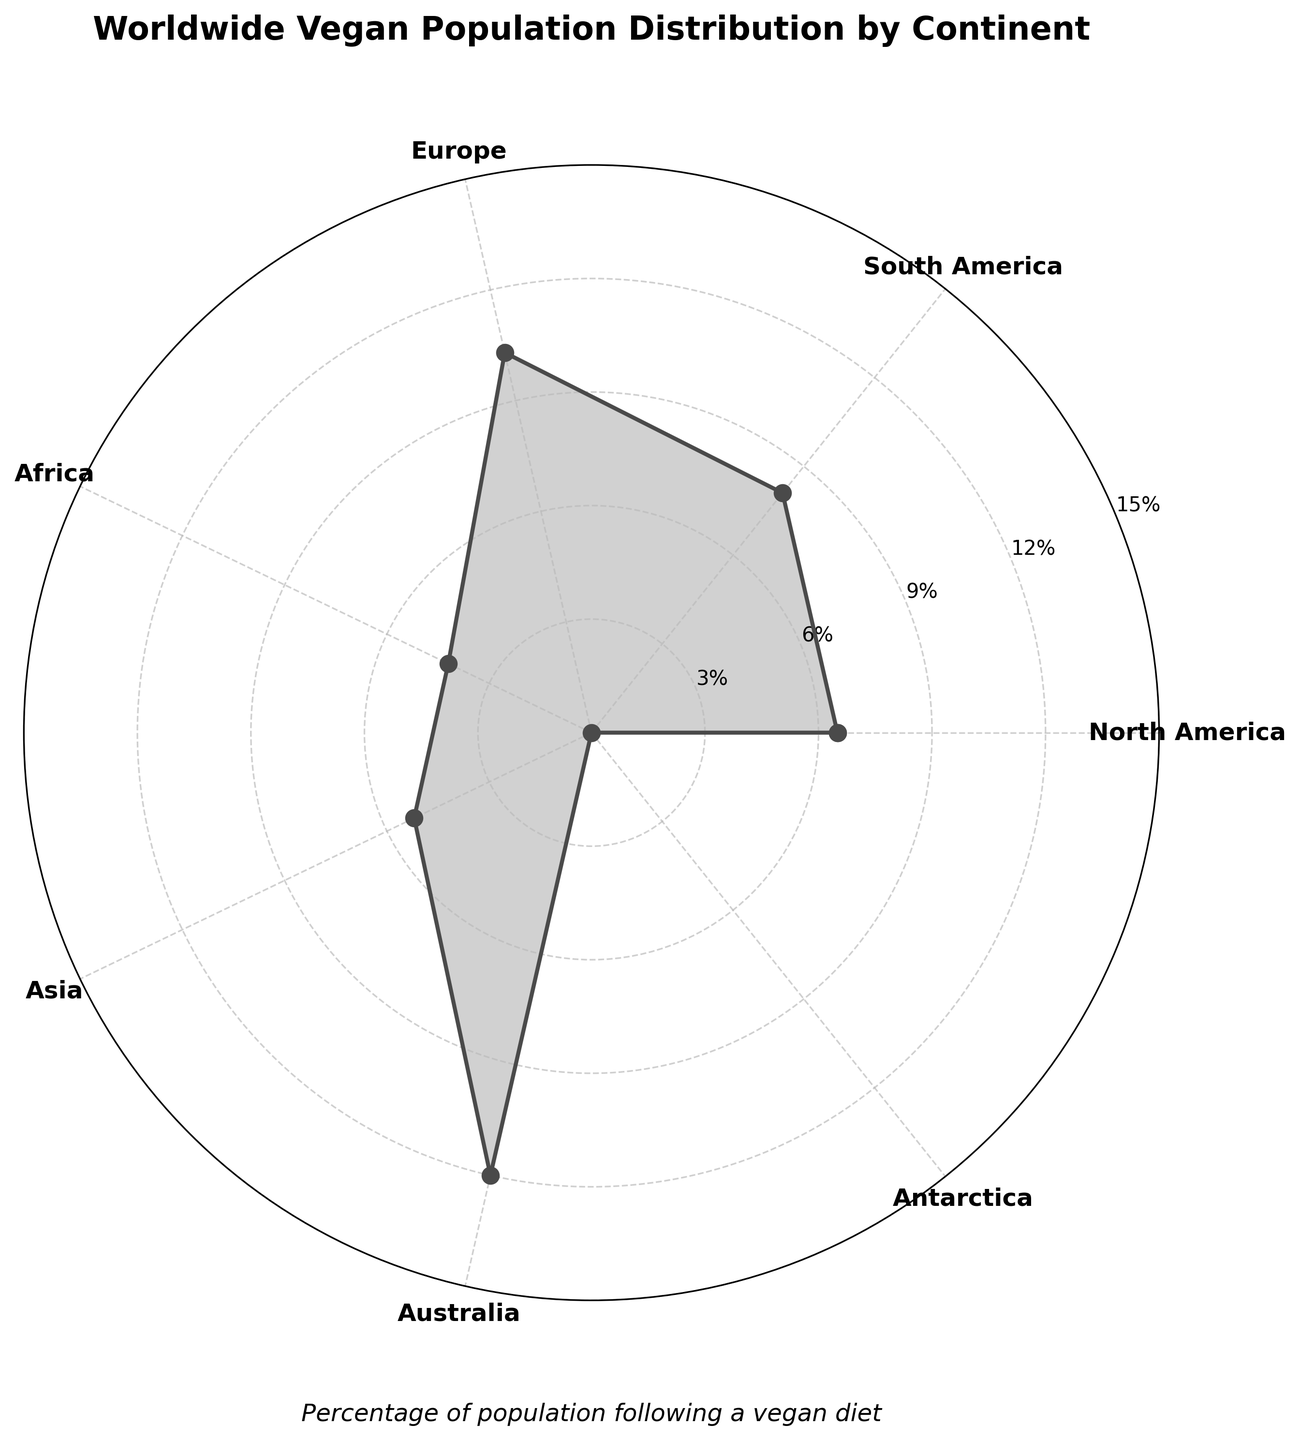How many continents are represented in the plot? There are data points for North America, South America, Europe, Africa, Asia, Australia, and Antarctica. By counting them, we get 7 continents.
Answer: 7 Which continent has the highest percentage of vegan population? By examining the plot, Australia has the highest percentage with 12.0%.
Answer: Australia Which continent has the lowest percentage of vegan population? According to the plot, Antarctica has the lowest percentage of vegan population, which is 0.0%.
Answer: Antarctica What is the difference in the percentage of vegan population between Europe and Africa? The vegan population percentage in Europe is 10.3% and in Africa is 4.2%. Subtracting these values (10.3% - 4.2%) gives us 6.1%.
Answer: 6.1% What is the average vegan population percentage across all continents? The percentages are 6.5% for North America, 8.1% for South America, 10.3% for Europe, 4.2% for Africa, 5.2% for Asia, 12.0% for Australia, and 0.0% for Antarctica. Summing these percentages (6.5 + 8.1 + 10.3 + 4.2 + 5.2 + 12.0 + 0.0) and dividing by the number of continents (7) gives an average of 6.61%.
Answer: 6.61% Is the vegan population percentage in North America greater than that in Asia? North America has a vegan population percentage of 6.5%, while Asia has 5.2%. Since 6.5% > 5.2%, the answer is yes.
Answer: Yes Which two continents have the closest vegan population percentages? By examining the plot, North America has 6.5% and Asia has 5.2%. The difference is 1.3%, which is the smallest among all pairs of continents.
Answer: North America and Asia What is the sum of the vegan population percentages for South America, Africa, and Australia? The percentages for these continents are 8.1% (South America), 4.2% (Africa), and 12.0% (Australia). Adding these gives 8.1 + 4.2 + 12.0 = 24.3%.
Answer: 24.3% What is the percentage difference between the continent with the highest and the continent with the lowest vegan population percentage? The highest percentage is 12.0% (Australia) and the lowest is 0.0% (Antarctica). The difference is 12.0% - 0.0% = 12.0%.
Answer: 12.0% Which continent is represented by the angle closest to 90 degrees on the polar plot? In the polar plot, the angles are proportionally distributed around the circle. Europe is positioned at the angle closest to 90 degrees.
Answer: Europe 